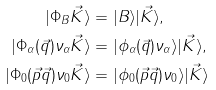Convert formula to latex. <formula><loc_0><loc_0><loc_500><loc_500>| \Phi _ { B } \vec { K } \rangle & = | B \rangle | \vec { K } \rangle , \\ | \Phi _ { \alpha } ( \vec { q } ) \nu _ { \alpha } \vec { K } \rangle & = | \phi _ { \alpha } ( \vec { q } ) \nu _ { \alpha } \rangle | \vec { K } \rangle , \\ | \Phi _ { 0 } ( \vec { p } \vec { q } ) \nu _ { 0 } \vec { K } \rangle & = | \phi _ { 0 } ( \vec { p } \vec { q } ) \nu _ { 0 } \rangle | \vec { K } \rangle</formula> 